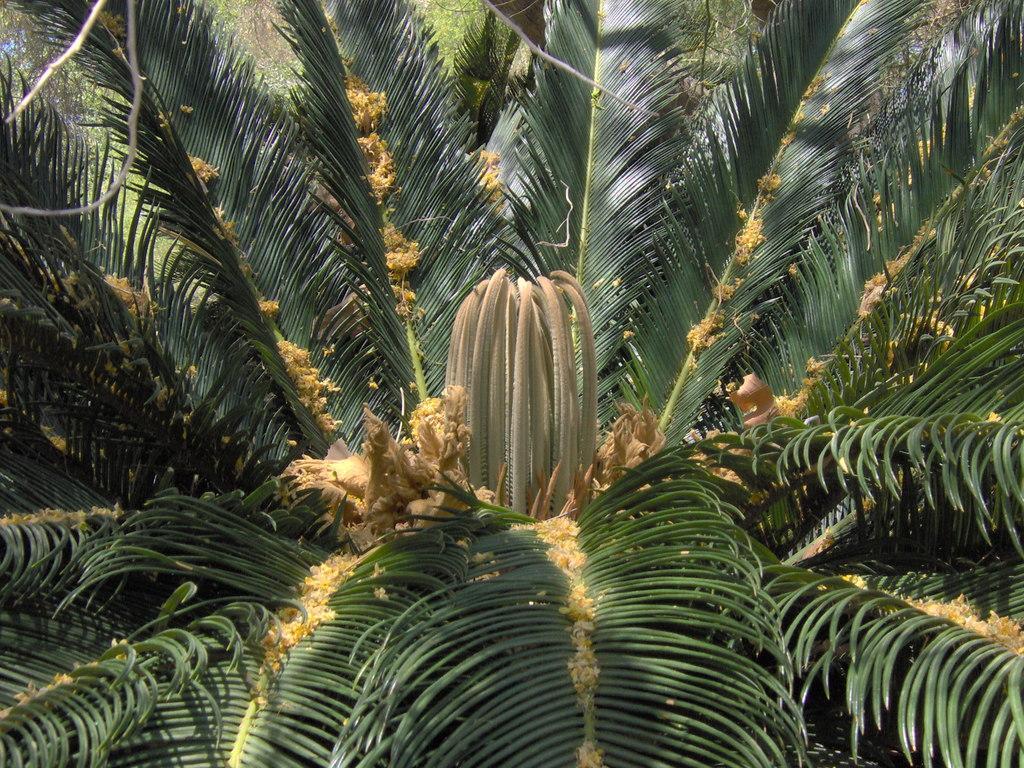In one or two sentences, can you explain what this image depicts? In this image there is a tree in the middle. There is a cactaceae flower in the middle. 